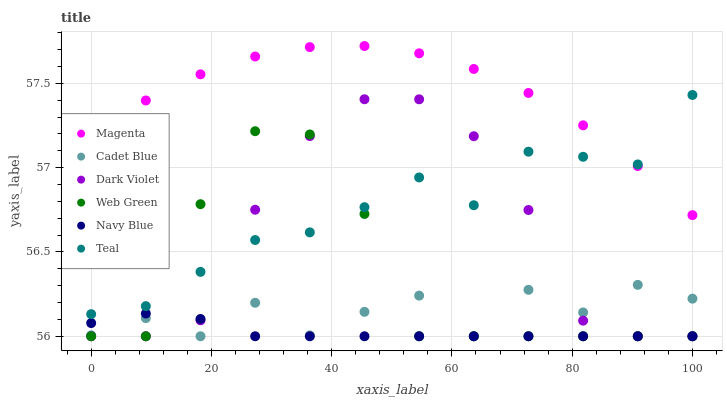Does Navy Blue have the minimum area under the curve?
Answer yes or no. Yes. Does Magenta have the maximum area under the curve?
Answer yes or no. Yes. Does Web Green have the minimum area under the curve?
Answer yes or no. No. Does Web Green have the maximum area under the curve?
Answer yes or no. No. Is Navy Blue the smoothest?
Answer yes or no. Yes. Is Cadet Blue the roughest?
Answer yes or no. Yes. Is Web Green the smoothest?
Answer yes or no. No. Is Web Green the roughest?
Answer yes or no. No. Does Cadet Blue have the lowest value?
Answer yes or no. Yes. Does Teal have the lowest value?
Answer yes or no. No. Does Magenta have the highest value?
Answer yes or no. Yes. Does Web Green have the highest value?
Answer yes or no. No. Is Cadet Blue less than Magenta?
Answer yes or no. Yes. Is Teal greater than Cadet Blue?
Answer yes or no. Yes. Does Navy Blue intersect Cadet Blue?
Answer yes or no. Yes. Is Navy Blue less than Cadet Blue?
Answer yes or no. No. Is Navy Blue greater than Cadet Blue?
Answer yes or no. No. Does Cadet Blue intersect Magenta?
Answer yes or no. No. 